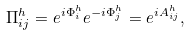Convert formula to latex. <formula><loc_0><loc_0><loc_500><loc_500>\Pi ^ { h } _ { i j } = e ^ { i \Phi ^ { h } _ { i } } e ^ { - i \Phi ^ { h } _ { j } } = e ^ { i A ^ { h } _ { i j } } ,</formula> 